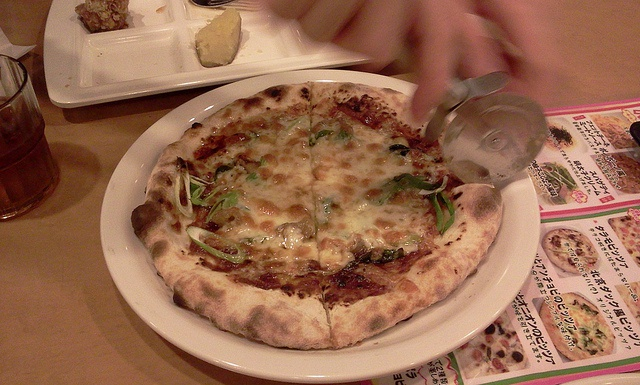Describe the objects in this image and their specific colors. I can see dining table in brown, tan, and maroon tones, pizza in maroon, gray, brown, and tan tones, people in maroon and brown tones, and cup in maroon and gray tones in this image. 